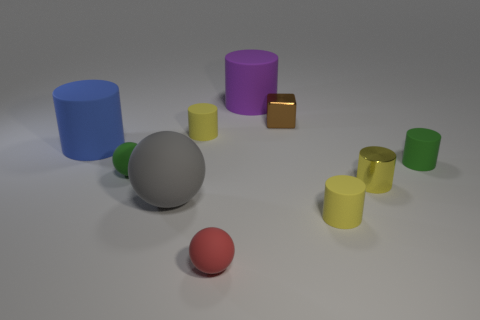Subtract all green spheres. How many spheres are left? 2 Subtract all big rubber cylinders. How many cylinders are left? 4 Subtract 0 brown balls. How many objects are left? 10 Subtract all cubes. How many objects are left? 9 Subtract 2 spheres. How many spheres are left? 1 Subtract all purple cylinders. Subtract all yellow spheres. How many cylinders are left? 5 Subtract all green cylinders. How many blue spheres are left? 0 Subtract all large gray metal blocks. Subtract all green balls. How many objects are left? 9 Add 1 green objects. How many green objects are left? 3 Add 3 green spheres. How many green spheres exist? 4 